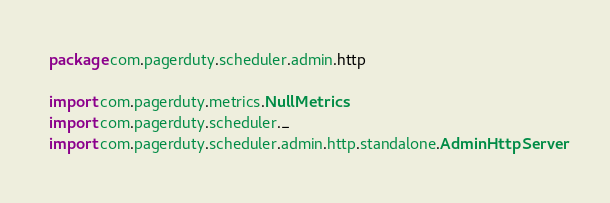<code> <loc_0><loc_0><loc_500><loc_500><_Scala_>package com.pagerduty.scheduler.admin.http

import com.pagerduty.metrics.NullMetrics
import com.pagerduty.scheduler._
import com.pagerduty.scheduler.admin.http.standalone.AdminHttpServer</code> 